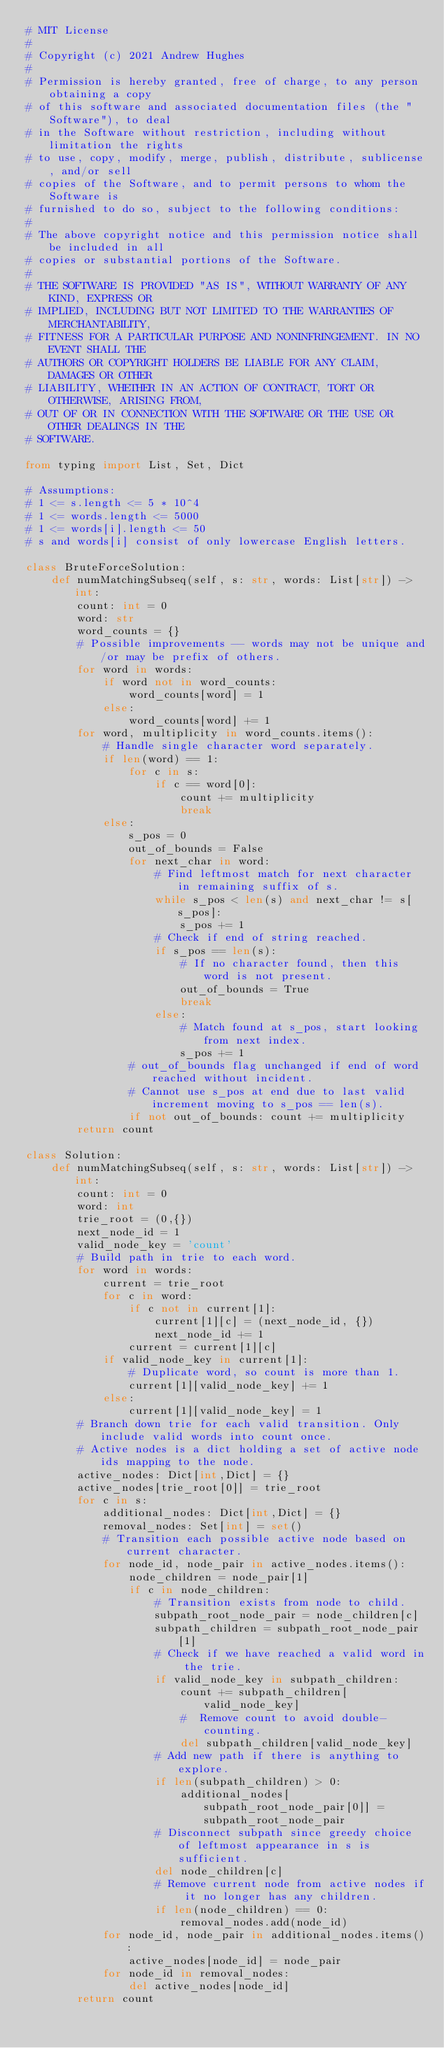Convert code to text. <code><loc_0><loc_0><loc_500><loc_500><_Python_># MIT License
#
# Copyright (c) 2021 Andrew Hughes
#
# Permission is hereby granted, free of charge, to any person obtaining a copy
# of this software and associated documentation files (the "Software"), to deal
# in the Software without restriction, including without limitation the rights
# to use, copy, modify, merge, publish, distribute, sublicense, and/or sell
# copies of the Software, and to permit persons to whom the Software is
# furnished to do so, subject to the following conditions:
#
# The above copyright notice and this permission notice shall be included in all
# copies or substantial portions of the Software.
#
# THE SOFTWARE IS PROVIDED "AS IS", WITHOUT WARRANTY OF ANY KIND, EXPRESS OR
# IMPLIED, INCLUDING BUT NOT LIMITED TO THE WARRANTIES OF MERCHANTABILITY,
# FITNESS FOR A PARTICULAR PURPOSE AND NONINFRINGEMENT. IN NO EVENT SHALL THE
# AUTHORS OR COPYRIGHT HOLDERS BE LIABLE FOR ANY CLAIM, DAMAGES OR OTHER
# LIABILITY, WHETHER IN AN ACTION OF CONTRACT, TORT OR OTHERWISE, ARISING FROM,
# OUT OF OR IN CONNECTION WITH THE SOFTWARE OR THE USE OR OTHER DEALINGS IN THE
# SOFTWARE.

from typing import List, Set, Dict

# Assumptions:
# 1 <= s.length <= 5 * 10^4
# 1 <= words.length <= 5000
# 1 <= words[i].length <= 50
# s and words[i] consist of only lowercase English letters.

class BruteForceSolution:
    def numMatchingSubseq(self, s: str, words: List[str]) -> int:
        count: int = 0
        word: str
        word_counts = {}
        # Possible improvements -- words may not be unique and/or may be prefix of others.
        for word in words:
            if word not in word_counts:
                word_counts[word] = 1
            else:
                word_counts[word] += 1
        for word, multiplicity in word_counts.items():
            # Handle single character word separately.
            if len(word) == 1:
                for c in s:
                    if c == word[0]:
                        count += multiplicity
                        break
            else:
                s_pos = 0
                out_of_bounds = False
                for next_char in word:
                    # Find leftmost match for next character in remaining suffix of s.
                    while s_pos < len(s) and next_char != s[s_pos]:
                        s_pos += 1
                    # Check if end of string reached.
                    if s_pos == len(s):
                        # If no character found, then this word is not present.
                        out_of_bounds = True
                        break
                    else:
                        # Match found at s_pos, start looking from next index.
                        s_pos += 1
                # out_of_bounds flag unchanged if end of word reached without incident.
                # Cannot use s_pos at end due to last valid increment moving to s_pos == len(s).
                if not out_of_bounds: count += multiplicity
        return count

class Solution:
    def numMatchingSubseq(self, s: str, words: List[str]) -> int:
        count: int = 0
        word: int
        trie_root = (0,{})
        next_node_id = 1
        valid_node_key = 'count'
        # Build path in trie to each word.
        for word in words:
            current = trie_root
            for c in word:
                if c not in current[1]:
                    current[1][c] = (next_node_id, {})
                    next_node_id += 1
                current = current[1][c]
            if valid_node_key in current[1]:
                # Duplicate word, so count is more than 1.
                current[1][valid_node_key] += 1
            else:
                current[1][valid_node_key] = 1
        # Branch down trie for each valid transition. Only include valid words into count once.
        # Active nodes is a dict holding a set of active node ids mapping to the node.
        active_nodes: Dict[int,Dict] = {}
        active_nodes[trie_root[0]] = trie_root
        for c in s:
            additional_nodes: Dict[int,Dict] = {}
            removal_nodes: Set[int] = set()
            # Transition each possible active node based on current character.
            for node_id, node_pair in active_nodes.items():
                node_children = node_pair[1]
                if c in node_children:
                    # Transition exists from node to child.
                    subpath_root_node_pair = node_children[c]
                    subpath_children = subpath_root_node_pair[1]
                    # Check if we have reached a valid word in the trie.
                    if valid_node_key in subpath_children:
                        count += subpath_children[valid_node_key]
                        #  Remove count to avoid double-counting.
                        del subpath_children[valid_node_key]
                    # Add new path if there is anything to explore.
                    if len(subpath_children) > 0:
                        additional_nodes[subpath_root_node_pair[0]] = subpath_root_node_pair
                    # Disconnect subpath since greedy choice of leftmost appearance in s is sufficient.
                    del node_children[c]
                    # Remove current node from active nodes if it no longer has any children.
                    if len(node_children) == 0:
                        removal_nodes.add(node_id)
            for node_id, node_pair in additional_nodes.items():
                active_nodes[node_id] = node_pair
            for node_id in removal_nodes:
                del active_nodes[node_id]
        return count</code> 